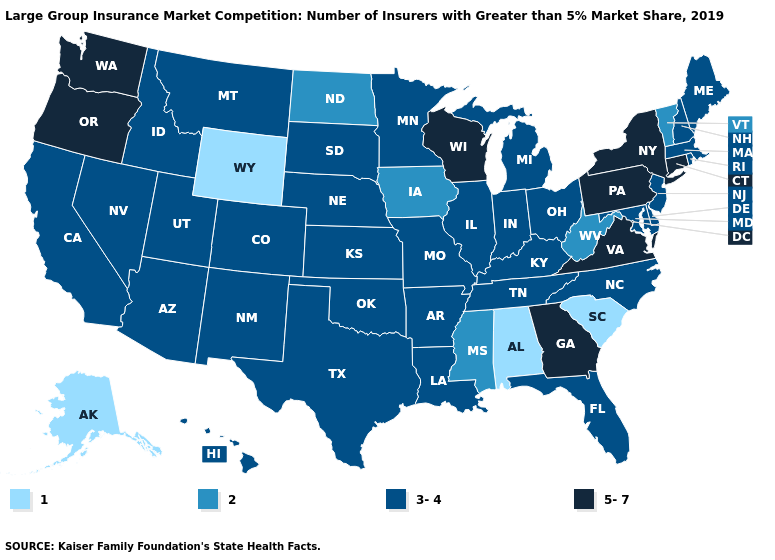Does Wyoming have a higher value than Virginia?
Concise answer only. No. Name the states that have a value in the range 3-4?
Give a very brief answer. Arizona, Arkansas, California, Colorado, Delaware, Florida, Hawaii, Idaho, Illinois, Indiana, Kansas, Kentucky, Louisiana, Maine, Maryland, Massachusetts, Michigan, Minnesota, Missouri, Montana, Nebraska, Nevada, New Hampshire, New Jersey, New Mexico, North Carolina, Ohio, Oklahoma, Rhode Island, South Dakota, Tennessee, Texas, Utah. Does Delaware have the highest value in the South?
Short answer required. No. Does the first symbol in the legend represent the smallest category?
Quick response, please. Yes. Does Connecticut have the highest value in the USA?
Short answer required. Yes. What is the highest value in the USA?
Give a very brief answer. 5-7. Does New Jersey have the highest value in the Northeast?
Quick response, please. No. What is the highest value in the MidWest ?
Write a very short answer. 5-7. Name the states that have a value in the range 5-7?
Be succinct. Connecticut, Georgia, New York, Oregon, Pennsylvania, Virginia, Washington, Wisconsin. Name the states that have a value in the range 2?
Give a very brief answer. Iowa, Mississippi, North Dakota, Vermont, West Virginia. Does Vermont have the lowest value in the Northeast?
Be succinct. Yes. Which states have the lowest value in the West?
Concise answer only. Alaska, Wyoming. What is the lowest value in states that border Mississippi?
Concise answer only. 1. What is the lowest value in the USA?
Keep it brief. 1. What is the value of Oklahoma?
Short answer required. 3-4. 